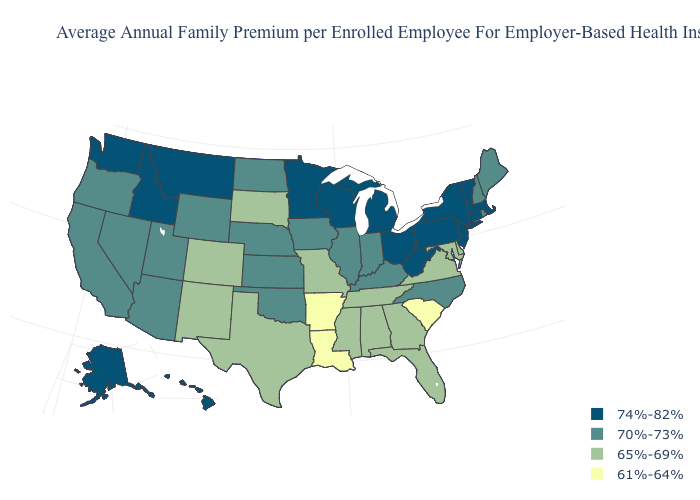Name the states that have a value in the range 65%-69%?
Be succinct. Alabama, Colorado, Delaware, Florida, Georgia, Maryland, Mississippi, Missouri, New Mexico, South Dakota, Tennessee, Texas, Virginia. What is the value of Rhode Island?
Give a very brief answer. 70%-73%. Does Texas have the lowest value in the South?
Quick response, please. No. Name the states that have a value in the range 61%-64%?
Write a very short answer. Arkansas, Louisiana, South Carolina. What is the value of Wisconsin?
Be succinct. 74%-82%. Does Kentucky have the same value as Connecticut?
Concise answer only. No. How many symbols are there in the legend?
Be succinct. 4. What is the value of Kentucky?
Give a very brief answer. 70%-73%. Which states have the lowest value in the USA?
Quick response, please. Arkansas, Louisiana, South Carolina. What is the highest value in the South ?
Keep it brief. 74%-82%. Name the states that have a value in the range 74%-82%?
Write a very short answer. Alaska, Connecticut, Hawaii, Idaho, Massachusetts, Michigan, Minnesota, Montana, New Jersey, New York, Ohio, Pennsylvania, Vermont, Washington, West Virginia, Wisconsin. Name the states that have a value in the range 61%-64%?
Keep it brief. Arkansas, Louisiana, South Carolina. What is the value of Idaho?
Write a very short answer. 74%-82%. Among the states that border Florida , which have the highest value?
Be succinct. Alabama, Georgia. Does Connecticut have the same value as New Jersey?
Short answer required. Yes. 